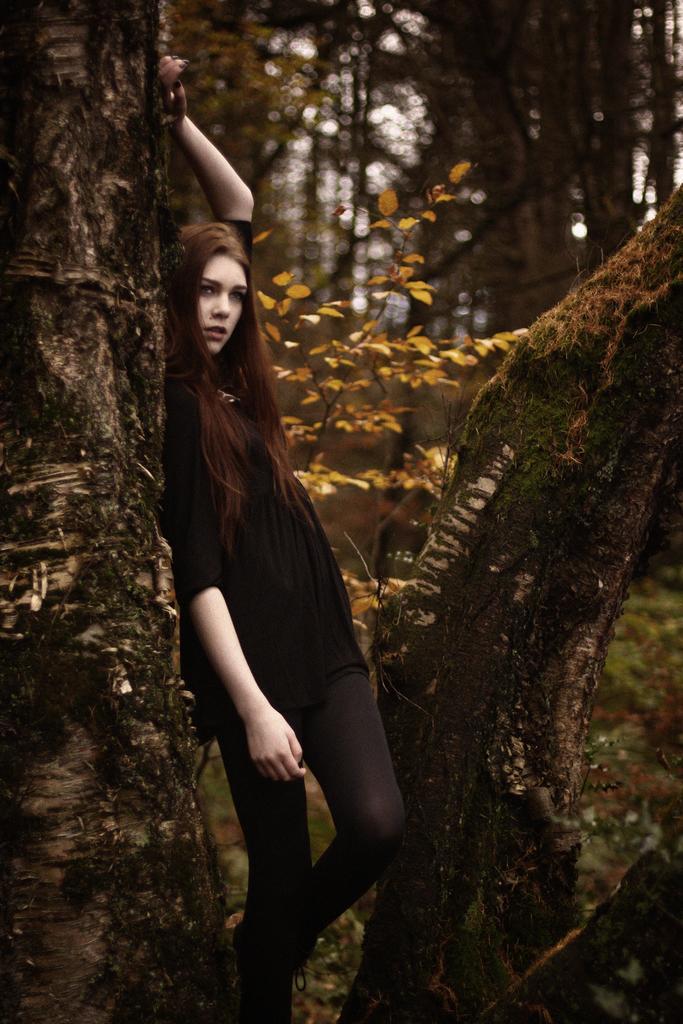Can you describe this image briefly? This image is taken outdoors. In the background there are many trees on the ground. In the middle of the image a girl is standing on the ground and she is leaning on the tree. 